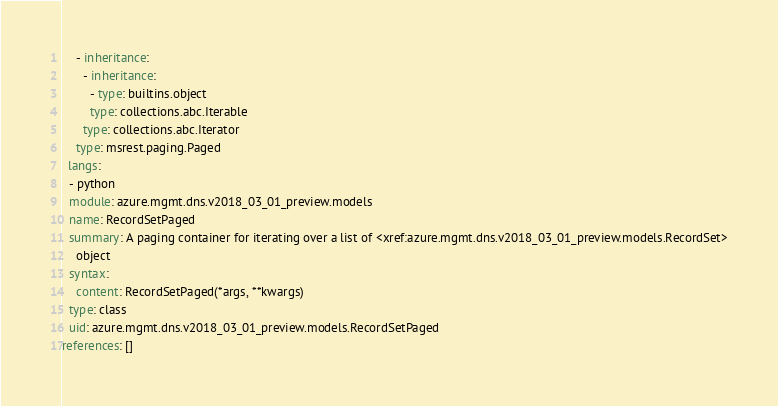Convert code to text. <code><loc_0><loc_0><loc_500><loc_500><_YAML_>    - inheritance:
      - inheritance:
        - type: builtins.object
        type: collections.abc.Iterable
      type: collections.abc.Iterator
    type: msrest.paging.Paged
  langs:
  - python
  module: azure.mgmt.dns.v2018_03_01_preview.models
  name: RecordSetPaged
  summary: A paging container for iterating over a list of <xref:azure.mgmt.dns.v2018_03_01_preview.models.RecordSet>
    object
  syntax:
    content: RecordSetPaged(*args, **kwargs)
  type: class
  uid: azure.mgmt.dns.v2018_03_01_preview.models.RecordSetPaged
references: []
</code> 